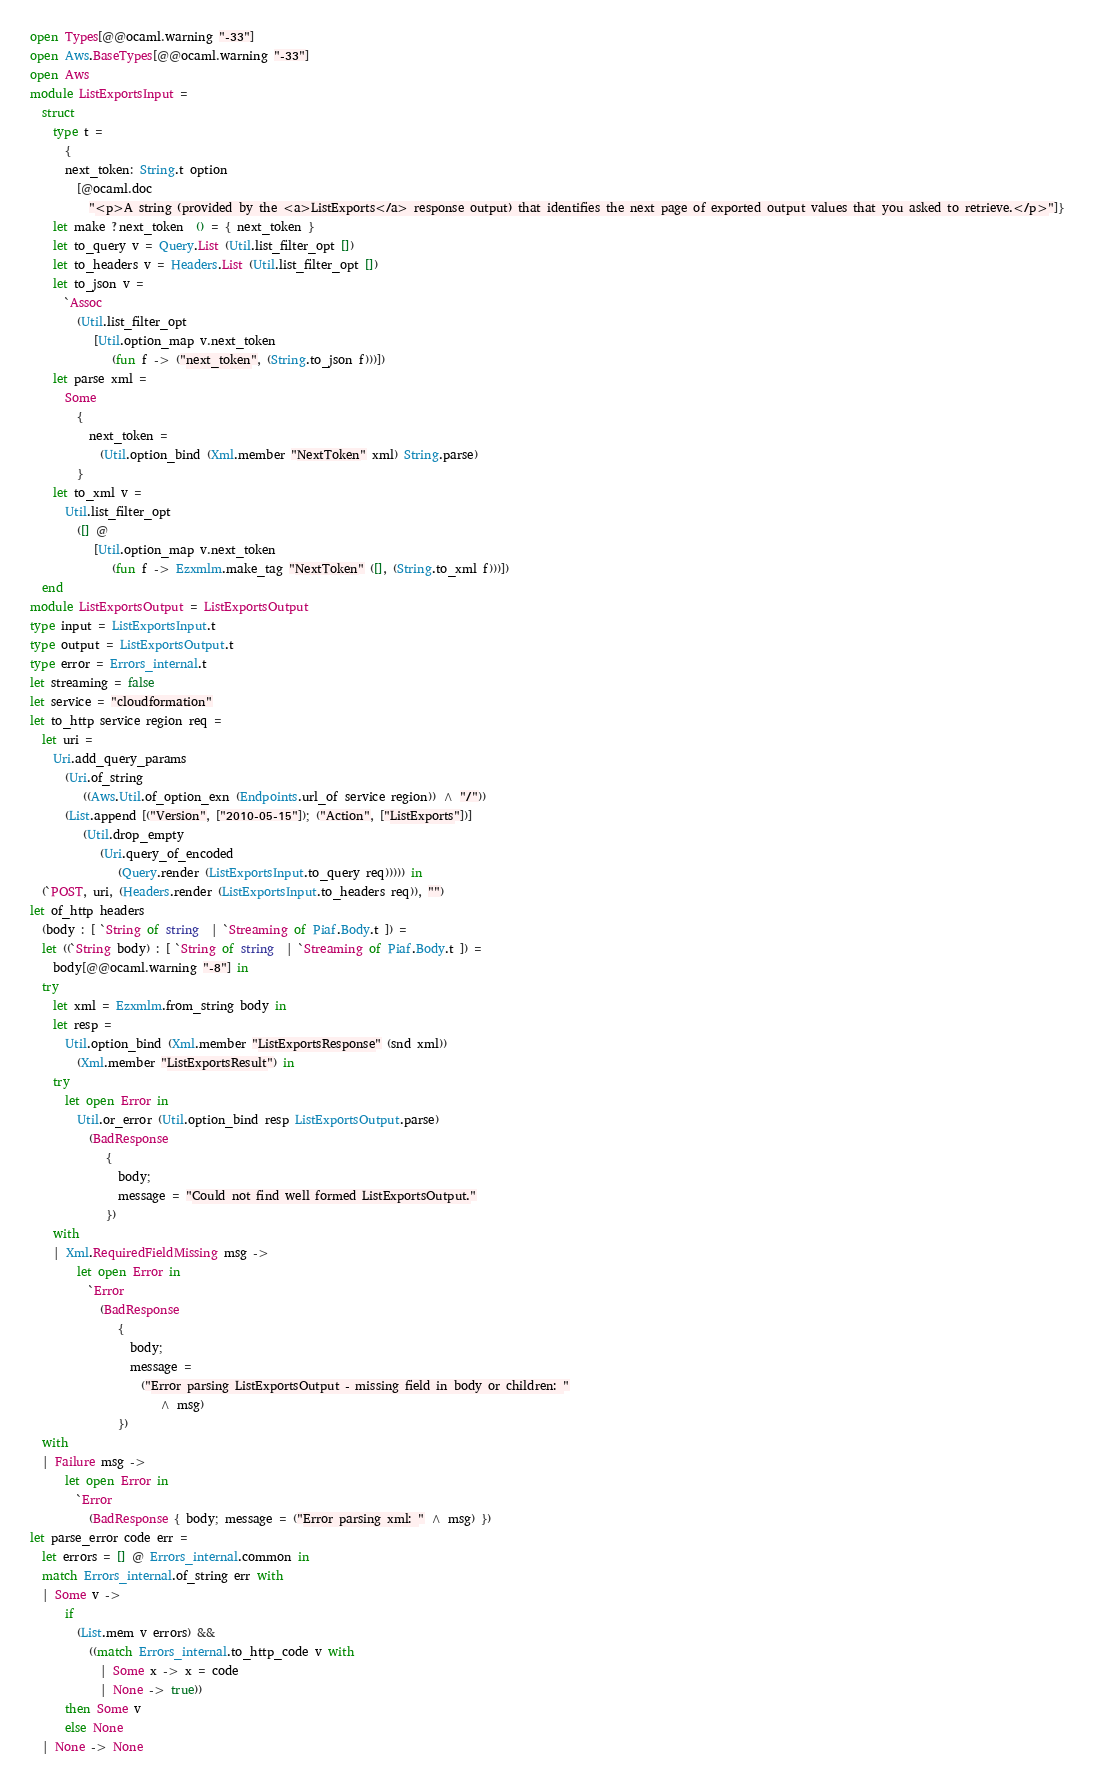Convert code to text. <code><loc_0><loc_0><loc_500><loc_500><_OCaml_>open Types[@@ocaml.warning "-33"]
open Aws.BaseTypes[@@ocaml.warning "-33"]
open Aws
module ListExportsInput =
  struct
    type t =
      {
      next_token: String.t option
        [@ocaml.doc
          "<p>A string (provided by the <a>ListExports</a> response output) that identifies the next page of exported output values that you asked to retrieve.</p>"]}
    let make ?next_token  () = { next_token }
    let to_query v = Query.List (Util.list_filter_opt [])
    let to_headers v = Headers.List (Util.list_filter_opt [])
    let to_json v =
      `Assoc
        (Util.list_filter_opt
           [Util.option_map v.next_token
              (fun f -> ("next_token", (String.to_json f)))])
    let parse xml =
      Some
        {
          next_token =
            (Util.option_bind (Xml.member "NextToken" xml) String.parse)
        }
    let to_xml v =
      Util.list_filter_opt
        ([] @
           [Util.option_map v.next_token
              (fun f -> Ezxmlm.make_tag "NextToken" ([], (String.to_xml f)))])
  end
module ListExportsOutput = ListExportsOutput
type input = ListExportsInput.t
type output = ListExportsOutput.t
type error = Errors_internal.t
let streaming = false
let service = "cloudformation"
let to_http service region req =
  let uri =
    Uri.add_query_params
      (Uri.of_string
         ((Aws.Util.of_option_exn (Endpoints.url_of service region)) ^ "/"))
      (List.append [("Version", ["2010-05-15"]); ("Action", ["ListExports"])]
         (Util.drop_empty
            (Uri.query_of_encoded
               (Query.render (ListExportsInput.to_query req))))) in
  (`POST, uri, (Headers.render (ListExportsInput.to_headers req)), "")
let of_http headers
  (body : [ `String of string  | `Streaming of Piaf.Body.t ]) =
  let ((`String body) : [ `String of string  | `Streaming of Piaf.Body.t ]) =
    body[@@ocaml.warning "-8"] in
  try
    let xml = Ezxmlm.from_string body in
    let resp =
      Util.option_bind (Xml.member "ListExportsResponse" (snd xml))
        (Xml.member "ListExportsResult") in
    try
      let open Error in
        Util.or_error (Util.option_bind resp ListExportsOutput.parse)
          (BadResponse
             {
               body;
               message = "Could not find well formed ListExportsOutput."
             })
    with
    | Xml.RequiredFieldMissing msg ->
        let open Error in
          `Error
            (BadResponse
               {
                 body;
                 message =
                   ("Error parsing ListExportsOutput - missing field in body or children: "
                      ^ msg)
               })
  with
  | Failure msg ->
      let open Error in
        `Error
          (BadResponse { body; message = ("Error parsing xml: " ^ msg) })
let parse_error code err =
  let errors = [] @ Errors_internal.common in
  match Errors_internal.of_string err with
  | Some v ->
      if
        (List.mem v errors) &&
          ((match Errors_internal.to_http_code v with
            | Some x -> x = code
            | None -> true))
      then Some v
      else None
  | None -> None</code> 